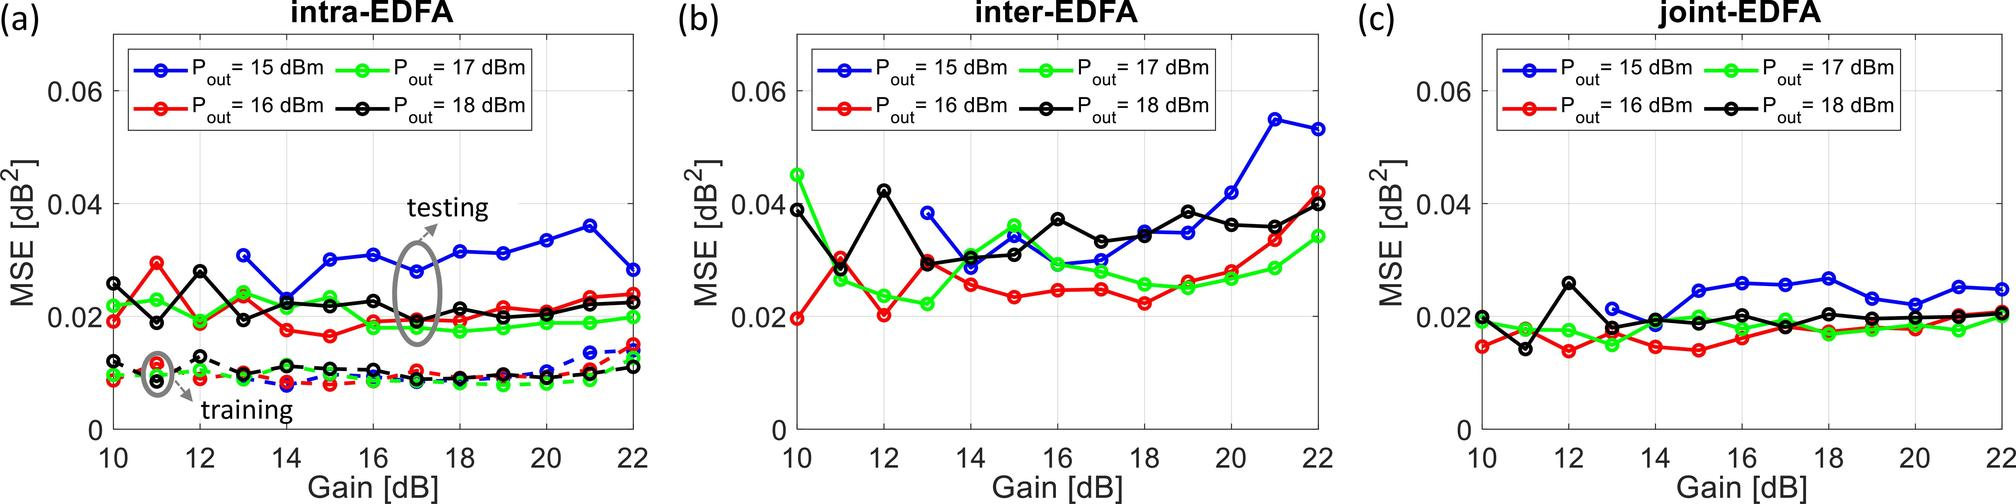Could you explain how the Mean Squared Error (MSE) responds to gain changes for the inter- and joint-EDFA configurations as seen in figures (b) and (c)? Certainly. While Figure (a) deals specifically with the intra-EDFA configuration, Figures (b) and (c), respectively, illustrate the MSE response for the inter- and joint-EDFA configurations. In Figure (b), corresponding to the inter-EDFA setup, the MSE's behavior is somewhat erratic as the gain increases. However, there is a general trend where MSE is relatively high at lower gains, decreases as the gain increases to an intermediate level, and then rises again at higher gains. The joint-EDFA configuration, depicted in Figure (c), shows MSE values that are quite stable across the gain range, with minor fluctuations but no clear increasing or decreasing trend. This suggests that the joint-EDFA maintains consistent performance over the examined gain settings, in contrast to the intra- and inter-EDFA configurations which display more prominent variations with gain change. 